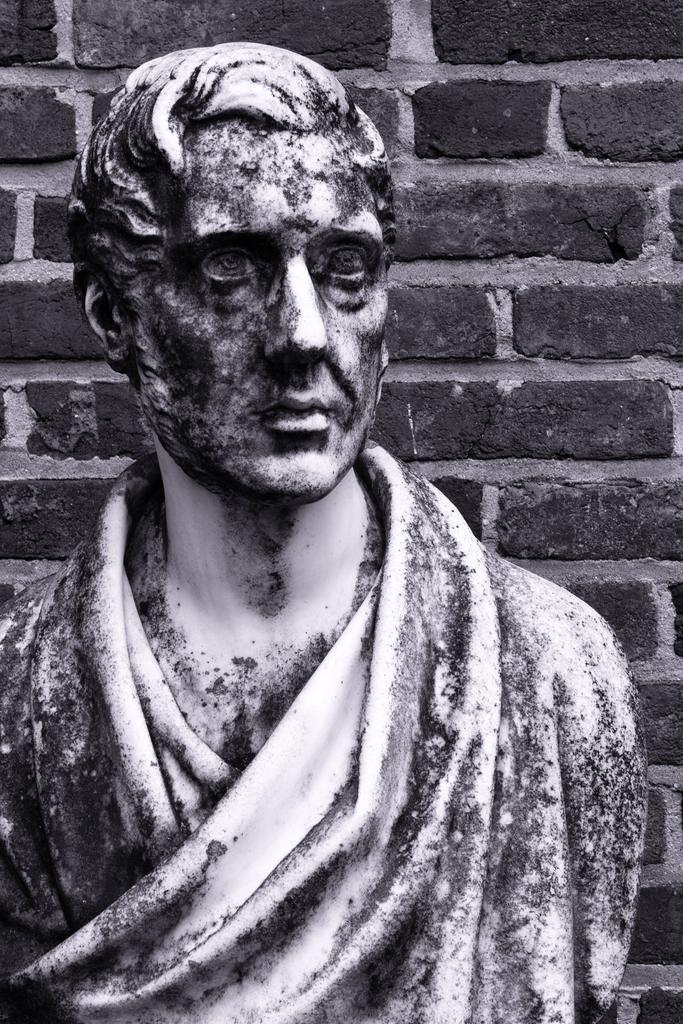Please provide a concise description of this image. In this picture I can see a sculpture of a person, behind we can see a brick wall. 